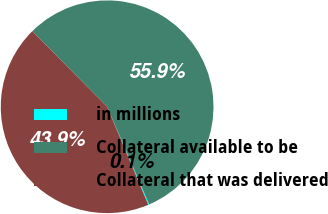<chart> <loc_0><loc_0><loc_500><loc_500><pie_chart><fcel>in millions<fcel>Collateral available to be<fcel>Collateral that was delivered<nl><fcel>0.15%<fcel>55.95%<fcel>43.91%<nl></chart> 